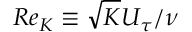Convert formula to latex. <formula><loc_0><loc_0><loc_500><loc_500>R e _ { K } \equiv \sqrt { K } U _ { \tau } / \nu</formula> 